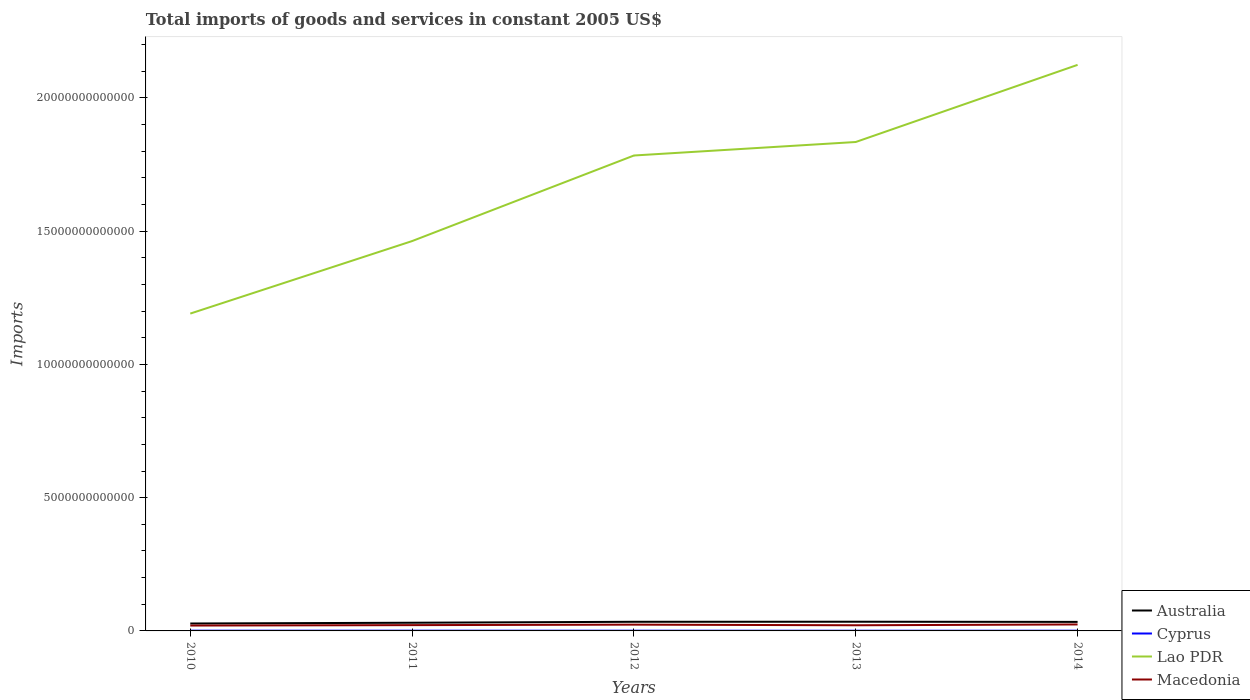Does the line corresponding to Australia intersect with the line corresponding to Lao PDR?
Offer a terse response. No. Across all years, what is the maximum total imports of goods and services in Macedonia?
Give a very brief answer. 2.02e+11. What is the total total imports of goods and services in Macedonia in the graph?
Make the answer very short. -3.07e+1. What is the difference between the highest and the second highest total imports of goods and services in Lao PDR?
Give a very brief answer. 9.33e+12. Is the total imports of goods and services in Lao PDR strictly greater than the total imports of goods and services in Australia over the years?
Your answer should be compact. No. What is the difference between two consecutive major ticks on the Y-axis?
Keep it short and to the point. 5.00e+12. Are the values on the major ticks of Y-axis written in scientific E-notation?
Provide a short and direct response. No. How many legend labels are there?
Provide a short and direct response. 4. What is the title of the graph?
Your response must be concise. Total imports of goods and services in constant 2005 US$. What is the label or title of the Y-axis?
Ensure brevity in your answer.  Imports. What is the Imports of Australia in 2010?
Ensure brevity in your answer.  2.79e+11. What is the Imports of Cyprus in 2010?
Offer a very short reply. 9.20e+09. What is the Imports of Lao PDR in 2010?
Offer a terse response. 1.19e+13. What is the Imports in Macedonia in 2010?
Offer a very short reply. 2.02e+11. What is the Imports of Australia in 2011?
Keep it short and to the point. 3.07e+11. What is the Imports of Cyprus in 2011?
Provide a short and direct response. 9.14e+09. What is the Imports of Lao PDR in 2011?
Offer a terse response. 1.46e+13. What is the Imports in Macedonia in 2011?
Ensure brevity in your answer.  2.18e+11. What is the Imports in Australia in 2012?
Ensure brevity in your answer.  3.43e+11. What is the Imports of Cyprus in 2012?
Keep it short and to the point. 8.72e+09. What is the Imports of Lao PDR in 2012?
Give a very brief answer. 1.78e+13. What is the Imports in Macedonia in 2012?
Offer a very short reply. 2.36e+11. What is the Imports of Australia in 2013?
Make the answer very short. 3.45e+11. What is the Imports of Cyprus in 2013?
Provide a short and direct response. 7.54e+09. What is the Imports of Lao PDR in 2013?
Your response must be concise. 1.83e+13. What is the Imports of Macedonia in 2013?
Offer a terse response. 2.12e+11. What is the Imports in Australia in 2014?
Provide a short and direct response. 3.39e+11. What is the Imports of Cyprus in 2014?
Make the answer very short. 8.14e+09. What is the Imports of Lao PDR in 2014?
Offer a very short reply. 2.12e+13. What is the Imports in Macedonia in 2014?
Your response must be concise. 2.43e+11. Across all years, what is the maximum Imports of Australia?
Keep it short and to the point. 3.45e+11. Across all years, what is the maximum Imports in Cyprus?
Ensure brevity in your answer.  9.20e+09. Across all years, what is the maximum Imports in Lao PDR?
Your answer should be compact. 2.12e+13. Across all years, what is the maximum Imports in Macedonia?
Give a very brief answer. 2.43e+11. Across all years, what is the minimum Imports of Australia?
Offer a terse response. 2.79e+11. Across all years, what is the minimum Imports of Cyprus?
Provide a succinct answer. 7.54e+09. Across all years, what is the minimum Imports in Lao PDR?
Give a very brief answer. 1.19e+13. Across all years, what is the minimum Imports in Macedonia?
Your answer should be very brief. 2.02e+11. What is the total Imports in Australia in the graph?
Ensure brevity in your answer.  1.61e+12. What is the total Imports of Cyprus in the graph?
Ensure brevity in your answer.  4.27e+1. What is the total Imports in Lao PDR in the graph?
Give a very brief answer. 8.40e+13. What is the total Imports of Macedonia in the graph?
Your response must be concise. 1.11e+12. What is the difference between the Imports in Australia in 2010 and that in 2011?
Keep it short and to the point. -2.86e+1. What is the difference between the Imports in Cyprus in 2010 and that in 2011?
Keep it short and to the point. 5.69e+07. What is the difference between the Imports of Lao PDR in 2010 and that in 2011?
Offer a terse response. -2.72e+12. What is the difference between the Imports in Macedonia in 2010 and that in 2011?
Offer a terse response. -1.61e+1. What is the difference between the Imports of Australia in 2010 and that in 2012?
Offer a terse response. -6.43e+1. What is the difference between the Imports of Cyprus in 2010 and that in 2012?
Keep it short and to the point. 4.77e+08. What is the difference between the Imports in Lao PDR in 2010 and that in 2012?
Give a very brief answer. -5.93e+12. What is the difference between the Imports of Macedonia in 2010 and that in 2012?
Your answer should be compact. -3.40e+1. What is the difference between the Imports of Australia in 2010 and that in 2013?
Provide a succinct answer. -6.65e+1. What is the difference between the Imports of Cyprus in 2010 and that in 2013?
Your response must be concise. 1.66e+09. What is the difference between the Imports in Lao PDR in 2010 and that in 2013?
Give a very brief answer. -6.44e+12. What is the difference between the Imports of Macedonia in 2010 and that in 2013?
Your answer should be compact. -1.04e+1. What is the difference between the Imports in Australia in 2010 and that in 2014?
Provide a succinct answer. -6.04e+1. What is the difference between the Imports of Cyprus in 2010 and that in 2014?
Offer a terse response. 1.06e+09. What is the difference between the Imports in Lao PDR in 2010 and that in 2014?
Offer a very short reply. -9.33e+12. What is the difference between the Imports in Macedonia in 2010 and that in 2014?
Provide a succinct answer. -4.12e+1. What is the difference between the Imports in Australia in 2011 and that in 2012?
Your answer should be very brief. -3.57e+1. What is the difference between the Imports in Cyprus in 2011 and that in 2012?
Your answer should be compact. 4.20e+08. What is the difference between the Imports of Lao PDR in 2011 and that in 2012?
Offer a very short reply. -3.21e+12. What is the difference between the Imports in Macedonia in 2011 and that in 2012?
Provide a succinct answer. -1.79e+1. What is the difference between the Imports of Australia in 2011 and that in 2013?
Make the answer very short. -3.79e+1. What is the difference between the Imports of Cyprus in 2011 and that in 2013?
Your answer should be very brief. 1.61e+09. What is the difference between the Imports of Lao PDR in 2011 and that in 2013?
Offer a terse response. -3.72e+12. What is the difference between the Imports in Macedonia in 2011 and that in 2013?
Your answer should be very brief. 5.66e+09. What is the difference between the Imports of Australia in 2011 and that in 2014?
Make the answer very short. -3.18e+1. What is the difference between the Imports in Cyprus in 2011 and that in 2014?
Give a very brief answer. 9.99e+08. What is the difference between the Imports in Lao PDR in 2011 and that in 2014?
Your response must be concise. -6.61e+12. What is the difference between the Imports of Macedonia in 2011 and that in 2014?
Give a very brief answer. -2.51e+1. What is the difference between the Imports in Australia in 2012 and that in 2013?
Your answer should be very brief. -2.19e+09. What is the difference between the Imports of Cyprus in 2012 and that in 2013?
Your answer should be very brief. 1.19e+09. What is the difference between the Imports in Lao PDR in 2012 and that in 2013?
Provide a short and direct response. -5.07e+11. What is the difference between the Imports of Macedonia in 2012 and that in 2013?
Offer a very short reply. 2.36e+1. What is the difference between the Imports in Australia in 2012 and that in 2014?
Ensure brevity in your answer.  3.91e+09. What is the difference between the Imports of Cyprus in 2012 and that in 2014?
Offer a very short reply. 5.79e+08. What is the difference between the Imports in Lao PDR in 2012 and that in 2014?
Offer a very short reply. -3.40e+12. What is the difference between the Imports of Macedonia in 2012 and that in 2014?
Give a very brief answer. -7.14e+09. What is the difference between the Imports of Australia in 2013 and that in 2014?
Your answer should be very brief. 6.10e+09. What is the difference between the Imports of Cyprus in 2013 and that in 2014?
Keep it short and to the point. -6.08e+08. What is the difference between the Imports in Lao PDR in 2013 and that in 2014?
Keep it short and to the point. -2.89e+12. What is the difference between the Imports in Macedonia in 2013 and that in 2014?
Give a very brief answer. -3.07e+1. What is the difference between the Imports in Australia in 2010 and the Imports in Cyprus in 2011?
Make the answer very short. 2.70e+11. What is the difference between the Imports of Australia in 2010 and the Imports of Lao PDR in 2011?
Make the answer very short. -1.43e+13. What is the difference between the Imports of Australia in 2010 and the Imports of Macedonia in 2011?
Your answer should be compact. 6.10e+1. What is the difference between the Imports in Cyprus in 2010 and the Imports in Lao PDR in 2011?
Give a very brief answer. -1.46e+13. What is the difference between the Imports of Cyprus in 2010 and the Imports of Macedonia in 2011?
Give a very brief answer. -2.08e+11. What is the difference between the Imports of Lao PDR in 2010 and the Imports of Macedonia in 2011?
Your response must be concise. 1.17e+13. What is the difference between the Imports in Australia in 2010 and the Imports in Cyprus in 2012?
Make the answer very short. 2.70e+11. What is the difference between the Imports of Australia in 2010 and the Imports of Lao PDR in 2012?
Your answer should be compact. -1.76e+13. What is the difference between the Imports of Australia in 2010 and the Imports of Macedonia in 2012?
Your answer should be very brief. 4.31e+1. What is the difference between the Imports of Cyprus in 2010 and the Imports of Lao PDR in 2012?
Make the answer very short. -1.78e+13. What is the difference between the Imports of Cyprus in 2010 and the Imports of Macedonia in 2012?
Your answer should be compact. -2.26e+11. What is the difference between the Imports of Lao PDR in 2010 and the Imports of Macedonia in 2012?
Your answer should be compact. 1.17e+13. What is the difference between the Imports in Australia in 2010 and the Imports in Cyprus in 2013?
Your answer should be very brief. 2.71e+11. What is the difference between the Imports in Australia in 2010 and the Imports in Lao PDR in 2013?
Give a very brief answer. -1.81e+13. What is the difference between the Imports in Australia in 2010 and the Imports in Macedonia in 2013?
Offer a very short reply. 6.67e+1. What is the difference between the Imports in Cyprus in 2010 and the Imports in Lao PDR in 2013?
Give a very brief answer. -1.83e+13. What is the difference between the Imports of Cyprus in 2010 and the Imports of Macedonia in 2013?
Your answer should be very brief. -2.03e+11. What is the difference between the Imports of Lao PDR in 2010 and the Imports of Macedonia in 2013?
Offer a terse response. 1.17e+13. What is the difference between the Imports of Australia in 2010 and the Imports of Cyprus in 2014?
Give a very brief answer. 2.71e+11. What is the difference between the Imports of Australia in 2010 and the Imports of Lao PDR in 2014?
Provide a short and direct response. -2.10e+13. What is the difference between the Imports of Australia in 2010 and the Imports of Macedonia in 2014?
Make the answer very short. 3.59e+1. What is the difference between the Imports in Cyprus in 2010 and the Imports in Lao PDR in 2014?
Give a very brief answer. -2.12e+13. What is the difference between the Imports in Cyprus in 2010 and the Imports in Macedonia in 2014?
Your answer should be compact. -2.34e+11. What is the difference between the Imports in Lao PDR in 2010 and the Imports in Macedonia in 2014?
Provide a succinct answer. 1.17e+13. What is the difference between the Imports of Australia in 2011 and the Imports of Cyprus in 2012?
Provide a short and direct response. 2.99e+11. What is the difference between the Imports of Australia in 2011 and the Imports of Lao PDR in 2012?
Your answer should be very brief. -1.75e+13. What is the difference between the Imports in Australia in 2011 and the Imports in Macedonia in 2012?
Provide a succinct answer. 7.16e+1. What is the difference between the Imports in Cyprus in 2011 and the Imports in Lao PDR in 2012?
Provide a short and direct response. -1.78e+13. What is the difference between the Imports of Cyprus in 2011 and the Imports of Macedonia in 2012?
Give a very brief answer. -2.26e+11. What is the difference between the Imports of Lao PDR in 2011 and the Imports of Macedonia in 2012?
Your answer should be very brief. 1.44e+13. What is the difference between the Imports of Australia in 2011 and the Imports of Cyprus in 2013?
Offer a terse response. 3.00e+11. What is the difference between the Imports of Australia in 2011 and the Imports of Lao PDR in 2013?
Your answer should be very brief. -1.80e+13. What is the difference between the Imports of Australia in 2011 and the Imports of Macedonia in 2013?
Offer a very short reply. 9.52e+1. What is the difference between the Imports in Cyprus in 2011 and the Imports in Lao PDR in 2013?
Offer a terse response. -1.83e+13. What is the difference between the Imports in Cyprus in 2011 and the Imports in Macedonia in 2013?
Give a very brief answer. -2.03e+11. What is the difference between the Imports in Lao PDR in 2011 and the Imports in Macedonia in 2013?
Offer a very short reply. 1.44e+13. What is the difference between the Imports of Australia in 2011 and the Imports of Cyprus in 2014?
Your response must be concise. 2.99e+11. What is the difference between the Imports of Australia in 2011 and the Imports of Lao PDR in 2014?
Your answer should be compact. -2.09e+13. What is the difference between the Imports in Australia in 2011 and the Imports in Macedonia in 2014?
Offer a terse response. 6.45e+1. What is the difference between the Imports in Cyprus in 2011 and the Imports in Lao PDR in 2014?
Your answer should be compact. -2.12e+13. What is the difference between the Imports in Cyprus in 2011 and the Imports in Macedonia in 2014?
Make the answer very short. -2.34e+11. What is the difference between the Imports in Lao PDR in 2011 and the Imports in Macedonia in 2014?
Your answer should be compact. 1.44e+13. What is the difference between the Imports in Australia in 2012 and the Imports in Cyprus in 2013?
Provide a short and direct response. 3.35e+11. What is the difference between the Imports in Australia in 2012 and the Imports in Lao PDR in 2013?
Give a very brief answer. -1.80e+13. What is the difference between the Imports of Australia in 2012 and the Imports of Macedonia in 2013?
Offer a very short reply. 1.31e+11. What is the difference between the Imports of Cyprus in 2012 and the Imports of Lao PDR in 2013?
Offer a terse response. -1.83e+13. What is the difference between the Imports in Cyprus in 2012 and the Imports in Macedonia in 2013?
Your response must be concise. -2.03e+11. What is the difference between the Imports in Lao PDR in 2012 and the Imports in Macedonia in 2013?
Your response must be concise. 1.76e+13. What is the difference between the Imports in Australia in 2012 and the Imports in Cyprus in 2014?
Your response must be concise. 3.35e+11. What is the difference between the Imports in Australia in 2012 and the Imports in Lao PDR in 2014?
Ensure brevity in your answer.  -2.09e+13. What is the difference between the Imports of Australia in 2012 and the Imports of Macedonia in 2014?
Your answer should be very brief. 1.00e+11. What is the difference between the Imports in Cyprus in 2012 and the Imports in Lao PDR in 2014?
Ensure brevity in your answer.  -2.12e+13. What is the difference between the Imports of Cyprus in 2012 and the Imports of Macedonia in 2014?
Provide a succinct answer. -2.34e+11. What is the difference between the Imports in Lao PDR in 2012 and the Imports in Macedonia in 2014?
Ensure brevity in your answer.  1.76e+13. What is the difference between the Imports of Australia in 2013 and the Imports of Cyprus in 2014?
Provide a short and direct response. 3.37e+11. What is the difference between the Imports of Australia in 2013 and the Imports of Lao PDR in 2014?
Provide a short and direct response. -2.09e+13. What is the difference between the Imports of Australia in 2013 and the Imports of Macedonia in 2014?
Your answer should be compact. 1.02e+11. What is the difference between the Imports in Cyprus in 2013 and the Imports in Lao PDR in 2014?
Your answer should be compact. -2.12e+13. What is the difference between the Imports in Cyprus in 2013 and the Imports in Macedonia in 2014?
Make the answer very short. -2.35e+11. What is the difference between the Imports of Lao PDR in 2013 and the Imports of Macedonia in 2014?
Provide a succinct answer. 1.81e+13. What is the average Imports of Australia per year?
Keep it short and to the point. 3.23e+11. What is the average Imports of Cyprus per year?
Give a very brief answer. 8.55e+09. What is the average Imports of Lao PDR per year?
Provide a short and direct response. 1.68e+13. What is the average Imports of Macedonia per year?
Ensure brevity in your answer.  2.22e+11. In the year 2010, what is the difference between the Imports in Australia and Imports in Cyprus?
Provide a succinct answer. 2.69e+11. In the year 2010, what is the difference between the Imports in Australia and Imports in Lao PDR?
Your answer should be compact. -1.16e+13. In the year 2010, what is the difference between the Imports in Australia and Imports in Macedonia?
Provide a succinct answer. 7.71e+1. In the year 2010, what is the difference between the Imports in Cyprus and Imports in Lao PDR?
Ensure brevity in your answer.  -1.19e+13. In the year 2010, what is the difference between the Imports of Cyprus and Imports of Macedonia?
Your response must be concise. -1.92e+11. In the year 2010, what is the difference between the Imports in Lao PDR and Imports in Macedonia?
Offer a terse response. 1.17e+13. In the year 2011, what is the difference between the Imports of Australia and Imports of Cyprus?
Provide a succinct answer. 2.98e+11. In the year 2011, what is the difference between the Imports in Australia and Imports in Lao PDR?
Your answer should be compact. -1.43e+13. In the year 2011, what is the difference between the Imports of Australia and Imports of Macedonia?
Your answer should be very brief. 8.96e+1. In the year 2011, what is the difference between the Imports of Cyprus and Imports of Lao PDR?
Ensure brevity in your answer.  -1.46e+13. In the year 2011, what is the difference between the Imports in Cyprus and Imports in Macedonia?
Your answer should be very brief. -2.09e+11. In the year 2011, what is the difference between the Imports of Lao PDR and Imports of Macedonia?
Make the answer very short. 1.44e+13. In the year 2012, what is the difference between the Imports of Australia and Imports of Cyprus?
Ensure brevity in your answer.  3.34e+11. In the year 2012, what is the difference between the Imports of Australia and Imports of Lao PDR?
Provide a short and direct response. -1.75e+13. In the year 2012, what is the difference between the Imports in Australia and Imports in Macedonia?
Your answer should be compact. 1.07e+11. In the year 2012, what is the difference between the Imports of Cyprus and Imports of Lao PDR?
Provide a short and direct response. -1.78e+13. In the year 2012, what is the difference between the Imports of Cyprus and Imports of Macedonia?
Give a very brief answer. -2.27e+11. In the year 2012, what is the difference between the Imports in Lao PDR and Imports in Macedonia?
Give a very brief answer. 1.76e+13. In the year 2013, what is the difference between the Imports in Australia and Imports in Cyprus?
Your response must be concise. 3.38e+11. In the year 2013, what is the difference between the Imports in Australia and Imports in Lao PDR?
Provide a succinct answer. -1.80e+13. In the year 2013, what is the difference between the Imports in Australia and Imports in Macedonia?
Your answer should be very brief. 1.33e+11. In the year 2013, what is the difference between the Imports in Cyprus and Imports in Lao PDR?
Offer a very short reply. -1.83e+13. In the year 2013, what is the difference between the Imports of Cyprus and Imports of Macedonia?
Your answer should be compact. -2.04e+11. In the year 2013, what is the difference between the Imports in Lao PDR and Imports in Macedonia?
Offer a terse response. 1.81e+13. In the year 2014, what is the difference between the Imports of Australia and Imports of Cyprus?
Ensure brevity in your answer.  3.31e+11. In the year 2014, what is the difference between the Imports of Australia and Imports of Lao PDR?
Your answer should be compact. -2.09e+13. In the year 2014, what is the difference between the Imports in Australia and Imports in Macedonia?
Offer a very short reply. 9.63e+1. In the year 2014, what is the difference between the Imports in Cyprus and Imports in Lao PDR?
Provide a short and direct response. -2.12e+13. In the year 2014, what is the difference between the Imports in Cyprus and Imports in Macedonia?
Ensure brevity in your answer.  -2.35e+11. In the year 2014, what is the difference between the Imports in Lao PDR and Imports in Macedonia?
Your answer should be compact. 2.10e+13. What is the ratio of the Imports of Australia in 2010 to that in 2011?
Your answer should be compact. 0.91. What is the ratio of the Imports of Cyprus in 2010 to that in 2011?
Offer a very short reply. 1.01. What is the ratio of the Imports of Lao PDR in 2010 to that in 2011?
Your response must be concise. 0.81. What is the ratio of the Imports of Macedonia in 2010 to that in 2011?
Make the answer very short. 0.93. What is the ratio of the Imports in Australia in 2010 to that in 2012?
Your response must be concise. 0.81. What is the ratio of the Imports of Cyprus in 2010 to that in 2012?
Offer a very short reply. 1.05. What is the ratio of the Imports of Lao PDR in 2010 to that in 2012?
Keep it short and to the point. 0.67. What is the ratio of the Imports of Macedonia in 2010 to that in 2012?
Offer a very short reply. 0.86. What is the ratio of the Imports in Australia in 2010 to that in 2013?
Your answer should be compact. 0.81. What is the ratio of the Imports of Cyprus in 2010 to that in 2013?
Give a very brief answer. 1.22. What is the ratio of the Imports of Lao PDR in 2010 to that in 2013?
Keep it short and to the point. 0.65. What is the ratio of the Imports of Macedonia in 2010 to that in 2013?
Your answer should be compact. 0.95. What is the ratio of the Imports in Australia in 2010 to that in 2014?
Offer a very short reply. 0.82. What is the ratio of the Imports in Cyprus in 2010 to that in 2014?
Make the answer very short. 1.13. What is the ratio of the Imports of Lao PDR in 2010 to that in 2014?
Your response must be concise. 0.56. What is the ratio of the Imports in Macedonia in 2010 to that in 2014?
Provide a short and direct response. 0.83. What is the ratio of the Imports in Australia in 2011 to that in 2012?
Ensure brevity in your answer.  0.9. What is the ratio of the Imports in Cyprus in 2011 to that in 2012?
Your answer should be compact. 1.05. What is the ratio of the Imports of Lao PDR in 2011 to that in 2012?
Provide a short and direct response. 0.82. What is the ratio of the Imports of Macedonia in 2011 to that in 2012?
Keep it short and to the point. 0.92. What is the ratio of the Imports in Australia in 2011 to that in 2013?
Keep it short and to the point. 0.89. What is the ratio of the Imports in Cyprus in 2011 to that in 2013?
Keep it short and to the point. 1.21. What is the ratio of the Imports in Lao PDR in 2011 to that in 2013?
Your answer should be very brief. 0.8. What is the ratio of the Imports in Macedonia in 2011 to that in 2013?
Offer a terse response. 1.03. What is the ratio of the Imports in Australia in 2011 to that in 2014?
Make the answer very short. 0.91. What is the ratio of the Imports of Cyprus in 2011 to that in 2014?
Your answer should be compact. 1.12. What is the ratio of the Imports of Lao PDR in 2011 to that in 2014?
Keep it short and to the point. 0.69. What is the ratio of the Imports in Macedonia in 2011 to that in 2014?
Provide a succinct answer. 0.9. What is the ratio of the Imports in Cyprus in 2012 to that in 2013?
Ensure brevity in your answer.  1.16. What is the ratio of the Imports in Lao PDR in 2012 to that in 2013?
Offer a terse response. 0.97. What is the ratio of the Imports in Macedonia in 2012 to that in 2013?
Ensure brevity in your answer.  1.11. What is the ratio of the Imports of Australia in 2012 to that in 2014?
Your answer should be very brief. 1.01. What is the ratio of the Imports in Cyprus in 2012 to that in 2014?
Provide a short and direct response. 1.07. What is the ratio of the Imports in Lao PDR in 2012 to that in 2014?
Offer a very short reply. 0.84. What is the ratio of the Imports of Macedonia in 2012 to that in 2014?
Offer a terse response. 0.97. What is the ratio of the Imports of Australia in 2013 to that in 2014?
Make the answer very short. 1.02. What is the ratio of the Imports in Cyprus in 2013 to that in 2014?
Offer a very short reply. 0.93. What is the ratio of the Imports in Lao PDR in 2013 to that in 2014?
Ensure brevity in your answer.  0.86. What is the ratio of the Imports in Macedonia in 2013 to that in 2014?
Provide a short and direct response. 0.87. What is the difference between the highest and the second highest Imports in Australia?
Ensure brevity in your answer.  2.19e+09. What is the difference between the highest and the second highest Imports of Cyprus?
Provide a succinct answer. 5.69e+07. What is the difference between the highest and the second highest Imports of Lao PDR?
Your answer should be compact. 2.89e+12. What is the difference between the highest and the second highest Imports of Macedonia?
Offer a terse response. 7.14e+09. What is the difference between the highest and the lowest Imports of Australia?
Your answer should be very brief. 6.65e+1. What is the difference between the highest and the lowest Imports of Cyprus?
Offer a very short reply. 1.66e+09. What is the difference between the highest and the lowest Imports of Lao PDR?
Your response must be concise. 9.33e+12. What is the difference between the highest and the lowest Imports in Macedonia?
Keep it short and to the point. 4.12e+1. 